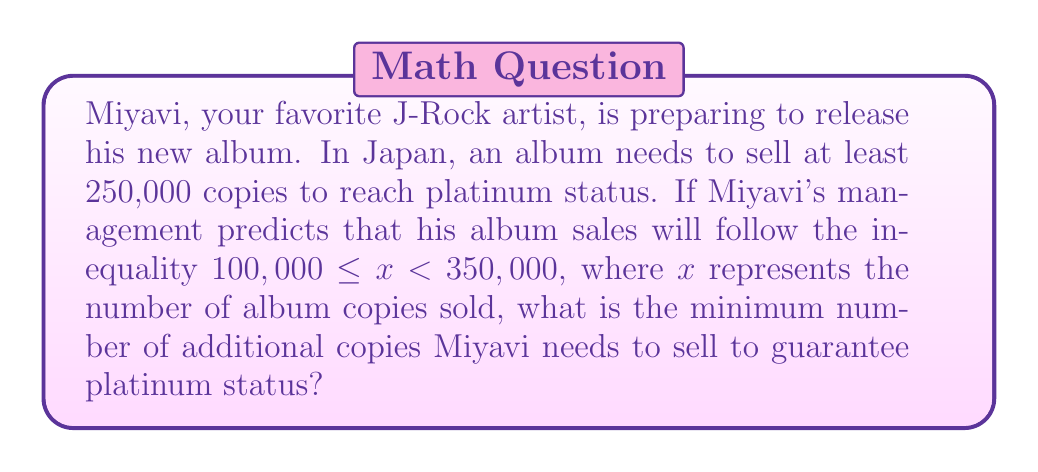Provide a solution to this math problem. Let's approach this step-by-step:

1) First, we need to understand the given information:
   - Platinum status requires at least 250,000 copies sold
   - Predicted sales are represented by the inequality: $100,000 \leq x < 350,000$

2) The lower bound of the predicted sales is 100,000 copies. This is the worst-case scenario we need to consider.

3) To find the minimum additional copies needed, we can set up the following equation:
   
   $100,000 + y = 250,000$

   Where $y$ represents the additional copies needed.

4) Solving for $y$:
   
   $y = 250,000 - 100,000 = 150,000$

5) Therefore, Miyavi needs to sell at least 150,000 additional copies to guarantee reaching platinum status, even in the worst-case scenario of his predicted sales.

6) We can verify this:
   - Worst-case scenario: $100,000 + 150,000 = 250,000$ (exactly platinum)
   - Best-case scenario: $350,000 + 150,000 = 500,000$ (well above platinum)

So, 150,000 additional copies will ensure platinum status regardless of where within the predicted range the actual sales fall.
Answer: Miyavi needs to sell a minimum of 150,000 additional copies to guarantee platinum status. 